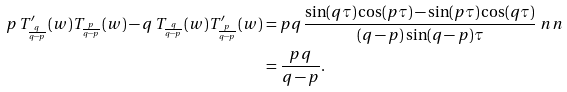Convert formula to latex. <formula><loc_0><loc_0><loc_500><loc_500>p \, T ^ { \prime } _ { \frac { q } { q - p } } ( w ) T _ { \frac { p } { q - p } } ( w ) - q \, T _ { \frac { q } { q - p } } ( w ) T ^ { \prime } _ { \frac { p } { q - p } } ( w ) & = p q \, \frac { \sin ( q \tau ) \cos ( p \tau ) - \sin ( p \tau ) \cos ( q \tau ) } { ( q - p ) \sin ( q - p ) \tau } \ n n \\ & = \frac { p q } { q - p } .</formula> 